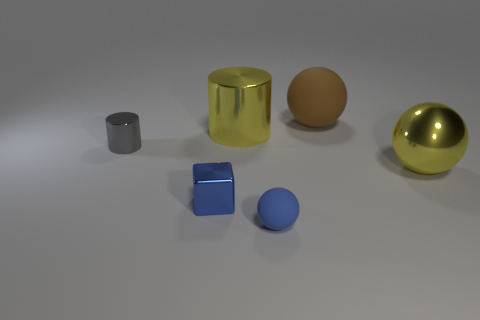Subtract all large spheres. How many spheres are left? 1 Subtract all blocks. How many objects are left? 5 Add 2 small brown metallic cylinders. How many objects exist? 8 Subtract all yellow cylinders. How many cylinders are left? 1 Subtract all gray balls. Subtract all brown cylinders. How many balls are left? 3 Subtract all brown cylinders. How many yellow spheres are left? 1 Subtract all balls. Subtract all yellow objects. How many objects are left? 1 Add 4 matte things. How many matte things are left? 6 Add 4 tiny shiny cylinders. How many tiny shiny cylinders exist? 5 Subtract 0 purple blocks. How many objects are left? 6 